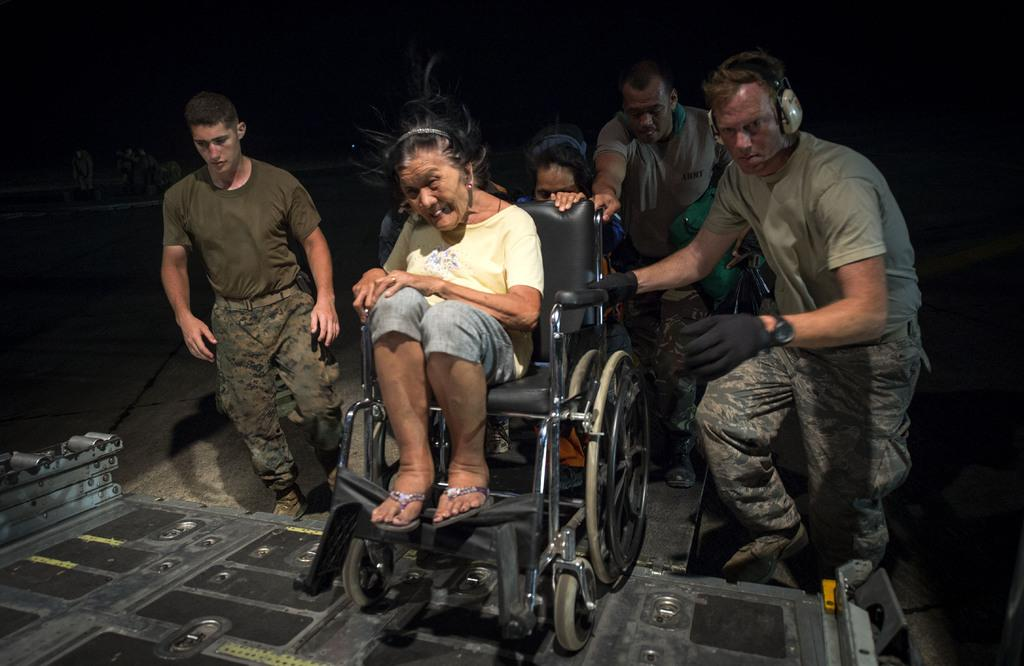How many people are in the image? There are people in the image, but the exact number is not specified. What is the woman in the image doing? The woman is sitting in a wheelchair. What is happening to the wheelchair in the image? The wheelchair is being pushed onto a platform. What are the hobbies of the team in the image? There is no mention of a team in the image, so it is not possible to determine their hobbies. 